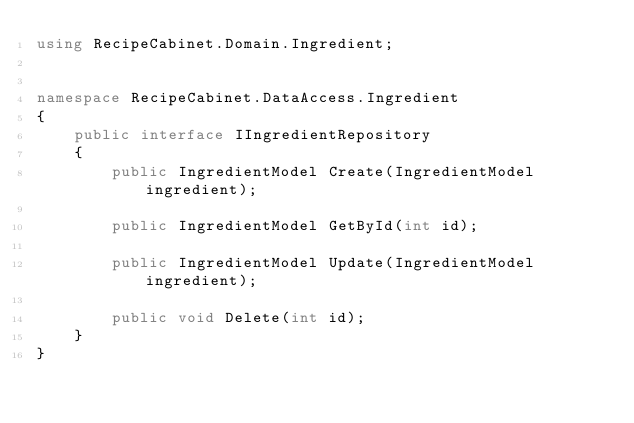<code> <loc_0><loc_0><loc_500><loc_500><_C#_>using RecipeCabinet.Domain.Ingredient;


namespace RecipeCabinet.DataAccess.Ingredient
{
    public interface IIngredientRepository
    {
        public IngredientModel Create(IngredientModel ingredient);

        public IngredientModel GetById(int id);

        public IngredientModel Update(IngredientModel ingredient);

        public void Delete(int id);
    }
}
</code> 